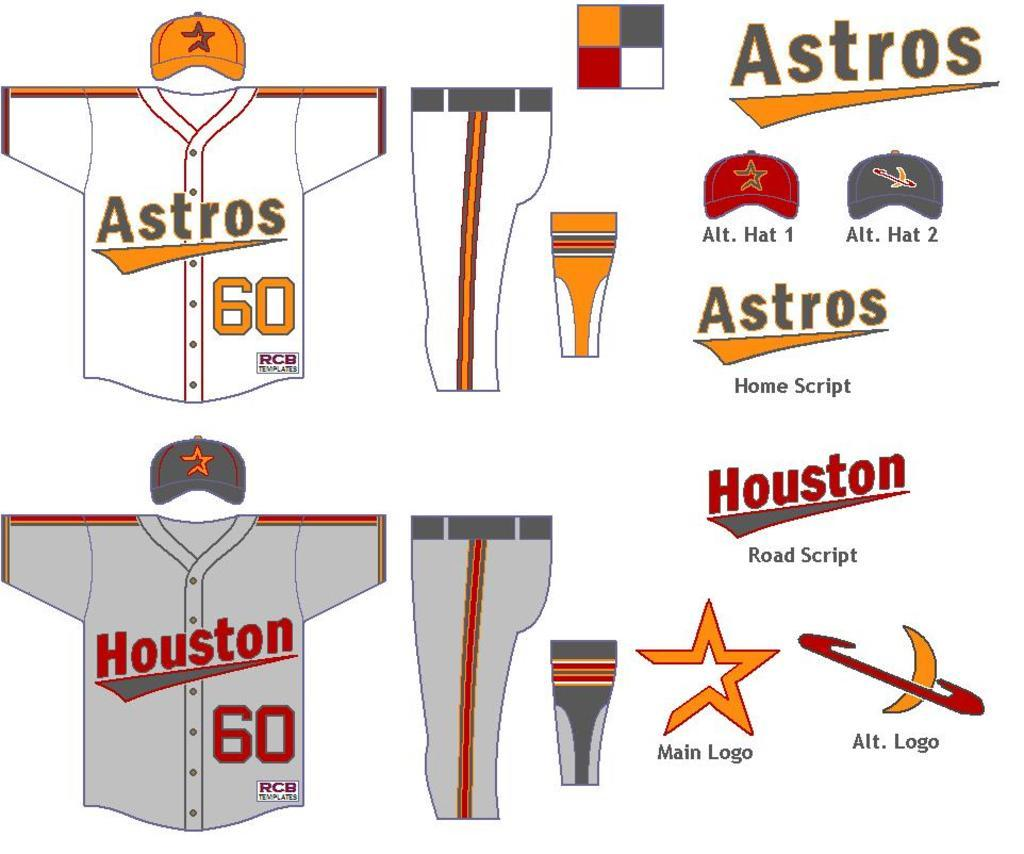Provide a one-sentence caption for the provided image. The Astros uniforms are shown from the front and side view. 